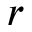Convert formula to latex. <formula><loc_0><loc_0><loc_500><loc_500>r</formula> 